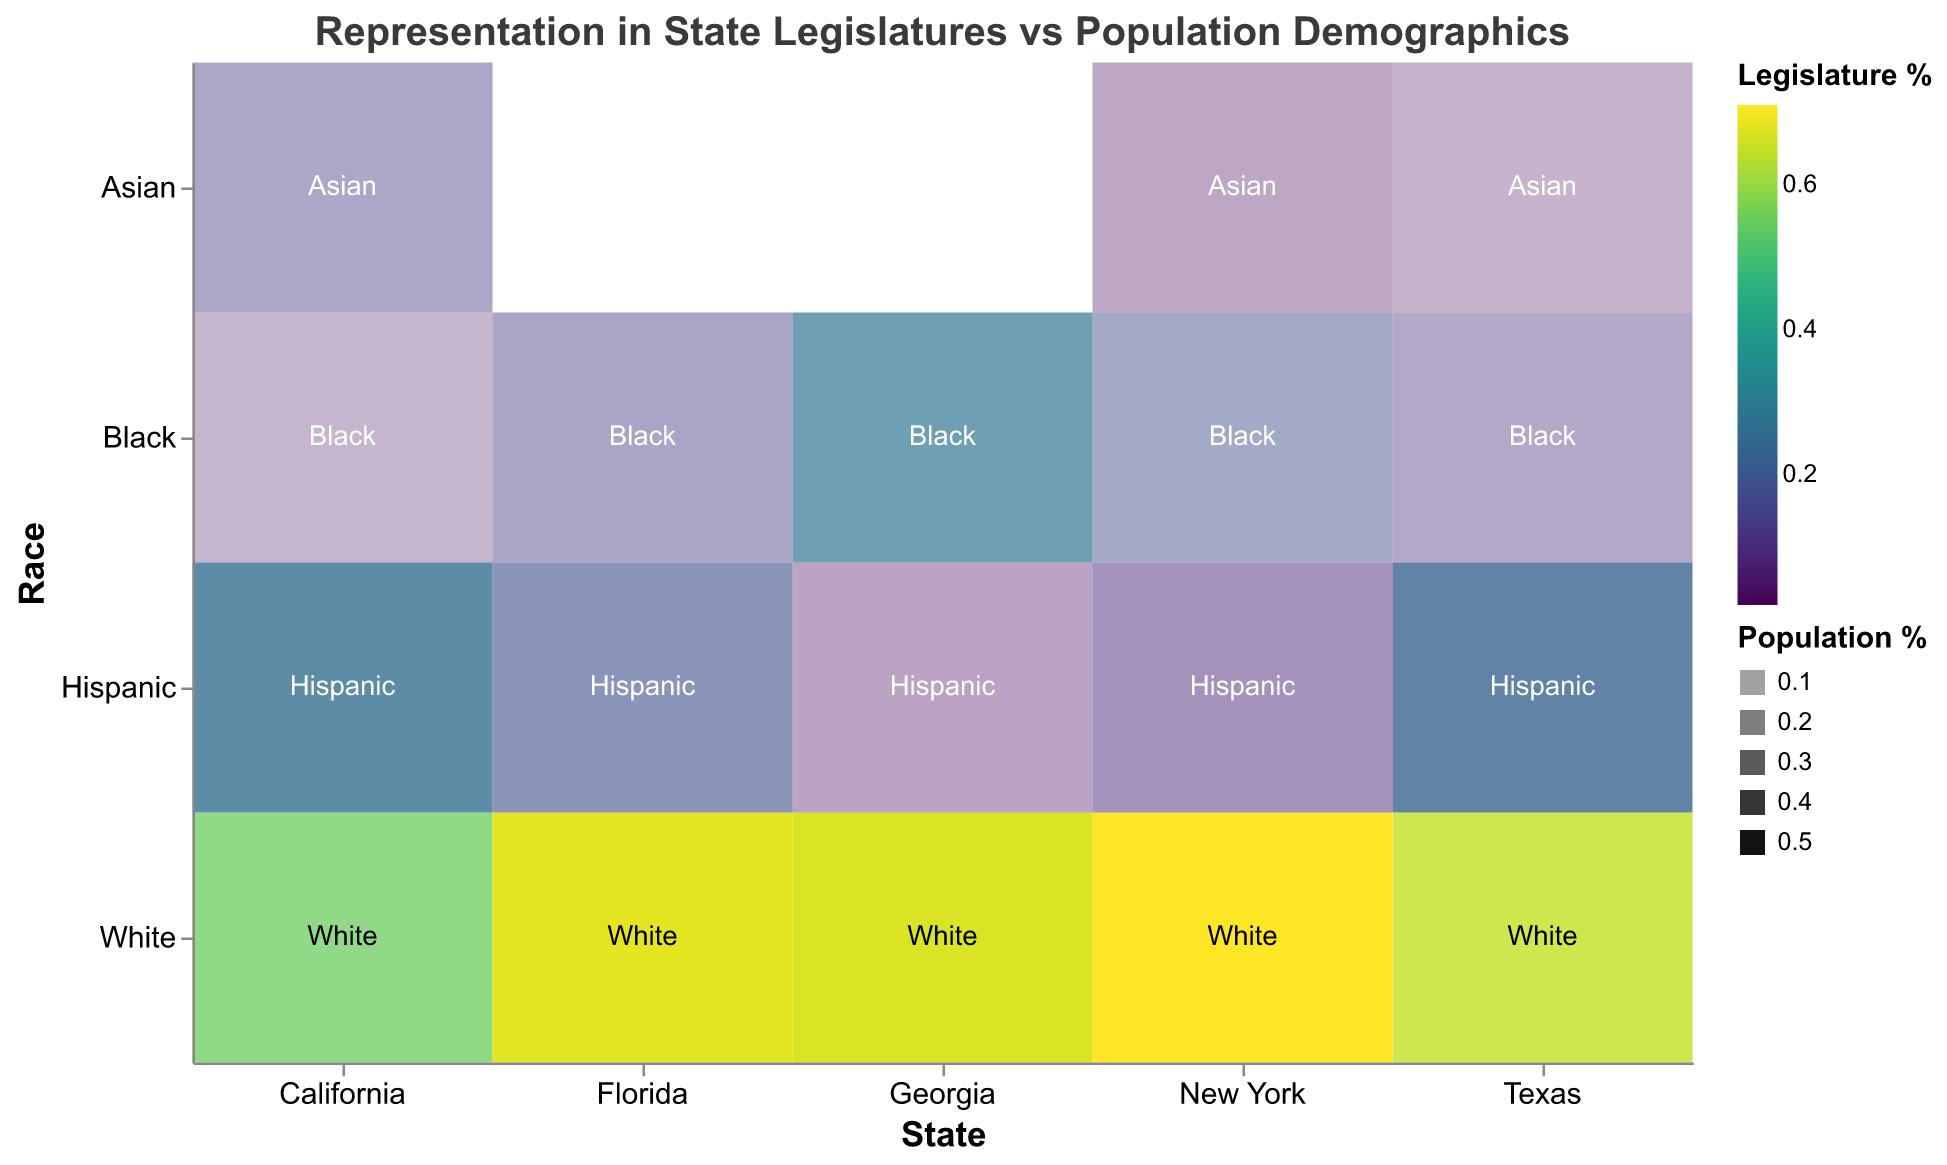What's the title of the figure? The title of the figure is typically found at the top, displaying a concise description of the visualization's purpose. Just look at the top of the figure to find the title.
Answer: Representation in State Legislatures vs Population Demographics Which state's legislature has the highest representation of White individuals, and what is the percentage? Check the section corresponding to White individuals for each state and find the state with the highest percentage.
Answer: New York, 71% Compare the percentage of Hispanic representation in the legislatures of California and Texas. Which state has a higher percentage, and by how much? Look at the percentage of Hispanic representation in the legislatures for both California (26%) and Texas (23%). Calculate the difference between these two percentages.
Answer: California, by 3% For the state of New York, is the Black population percentage higher or lower than their representation in the legislature? Find the figures for New York's Black population percentage (17.6%) and their legislative representation (17%). Compare the two values to determine which is higher.
Answer: Higher Which state shows the most significant underrepresentation of Hispanics in its legislature compared to their population percentage? For each state, calculate the difference between the population percentage and the legislative percentage for Hispanics. The state with the largest difference indicates the most significant underrepresentation.
Answer: Texas (39.7% - 23% = 16.7%) What is the average percentage of White representation in the state legislatures for all listed states? Add up the percentages of White representation across all states and then divide by the number of states to get the average. (55% + 65% + 71% + 68% + 67%) / 5 = 65.2%
Answer: 65.2% Which race has the highest representation in the legislature of Georgia and what is the percentage? Look at the representation percentages for each race in Georgia and identify the highest value.
Answer: White, 67% How does the percentage of Black representation in Florida's legislature compare to the total Black population percentage in the state? Compare the percentage of Black representation in Florida's legislature (14%) with the Black population percentage in the state (16.9%). Determine if it is higher, lower, or equal.
Answer: Lower Which state exhibits the lowest representation of Asians in its legislature relative to their population percentage? Calculate the representation gap for Asians in each state by subtracting the legislative percentage from the population percentage. The state with the highest gap indicates the lowest relative representation.
Answer: Texas (5.2% - 2% = 3.2%) Which state has the most proportional representation of its demographic groups in its legislature? For each state, analyze the differences between the legislative and population percentages across all demographic groups. The state with the smallest differences overall would have the most proportional representation.
Answer: California 